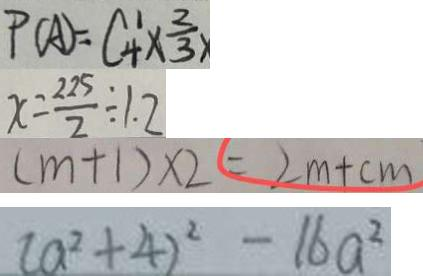Convert formula to latex. <formula><loc_0><loc_0><loc_500><loc_500>P ( A ) = C ^ { 1 } _ { 4 } \times \frac { 2 } { 3 } \times 
 x = \frac { 2 2 5 } { 2 } \div 1 . 2 
 ( m + 1 ) \times 2 = 2 m + c m 
 ( a ^ { 2 } + 4 ) ^ { 2 } - 1 6 a ^ { 2 }</formula> 